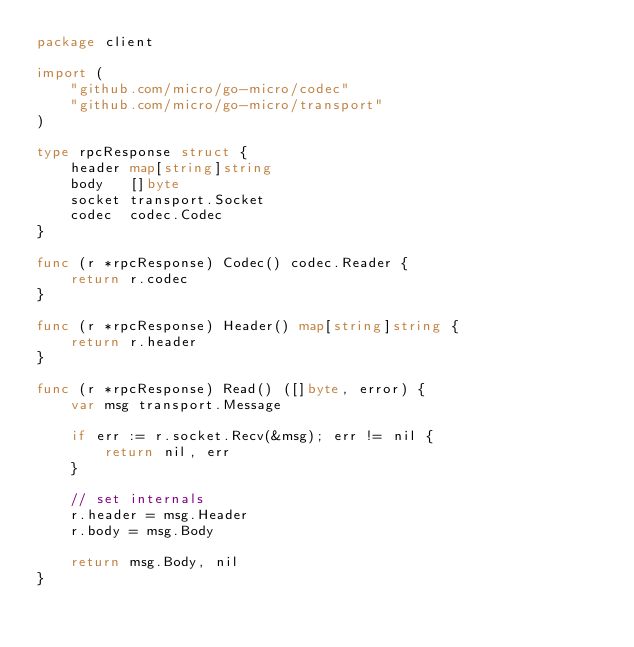<code> <loc_0><loc_0><loc_500><loc_500><_Go_>package client

import (
	"github.com/micro/go-micro/codec"
	"github.com/micro/go-micro/transport"
)

type rpcResponse struct {
	header map[string]string
	body   []byte
	socket transport.Socket
	codec  codec.Codec
}

func (r *rpcResponse) Codec() codec.Reader {
	return r.codec
}

func (r *rpcResponse) Header() map[string]string {
	return r.header
}

func (r *rpcResponse) Read() ([]byte, error) {
	var msg transport.Message

	if err := r.socket.Recv(&msg); err != nil {
		return nil, err
	}

	// set internals
	r.header = msg.Header
	r.body = msg.Body

	return msg.Body, nil
}
</code> 